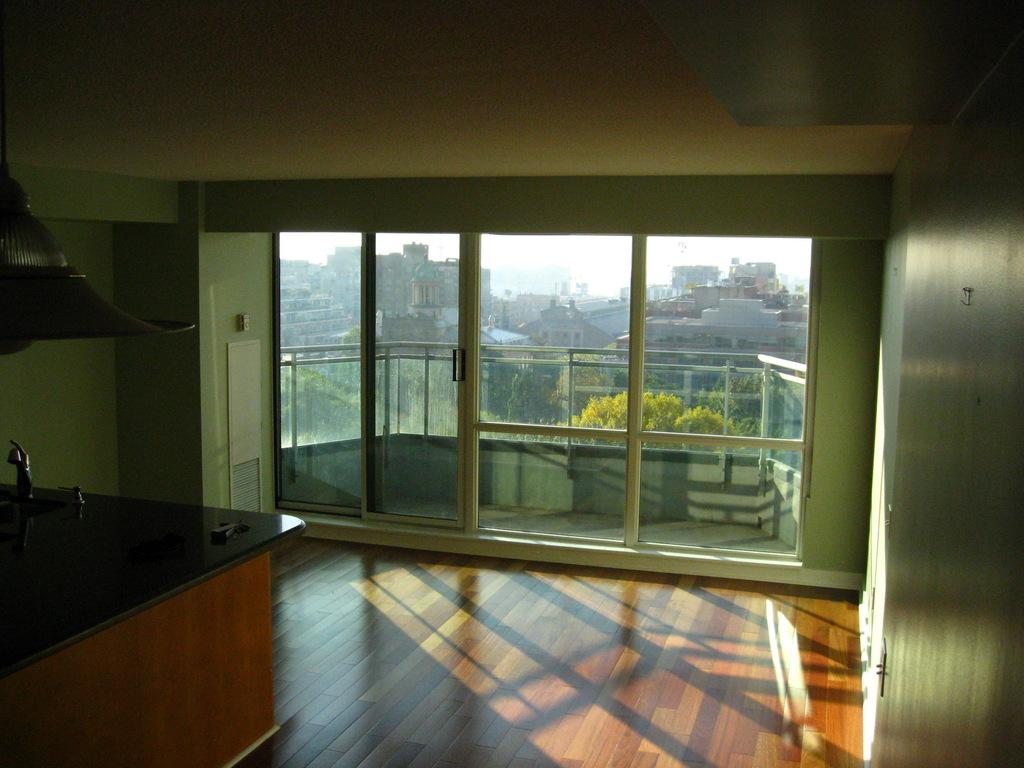What surface is present in the foreground of the image? There is a counter top in the image. What type of door can be seen in the background of the image? There is a glass door in the background of the image. What type of vegetation is visible in the background of the image? There are trees with green color in the background of the image. What type of structures are visible in the background of the image? There are buildings in the background of the image. What is visible in the sky in the image? The sky is visible in the image and has a white color. What type of operation is being performed on the mountain in the image? There is no mountain present in the image, and therefore no operation is being performed on it. 